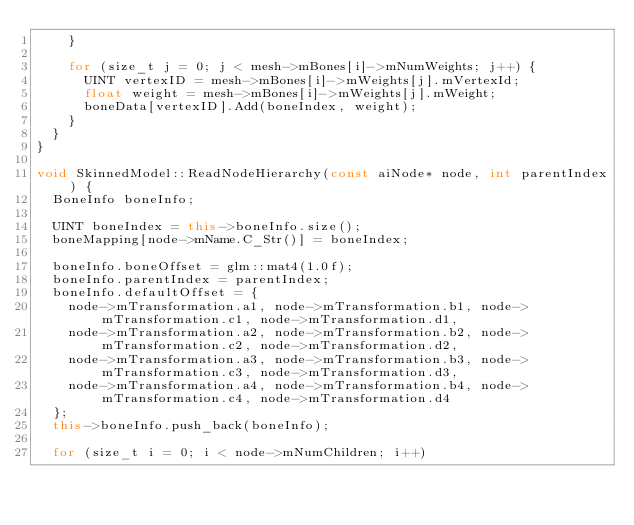<code> <loc_0><loc_0><loc_500><loc_500><_C++_>		}

		for (size_t j = 0; j < mesh->mBones[i]->mNumWeights; j++) {
			UINT vertexID = mesh->mBones[i]->mWeights[j].mVertexId;
			float weight = mesh->mBones[i]->mWeights[j].mWeight;
			boneData[vertexID].Add(boneIndex, weight);
		}
	}
}

void SkinnedModel::ReadNodeHierarchy(const aiNode* node, int parentIndex) {
	BoneInfo boneInfo;

	UINT boneIndex = this->boneInfo.size();
	boneMapping[node->mName.C_Str()] = boneIndex;

	boneInfo.boneOffset = glm::mat4(1.0f);
	boneInfo.parentIndex = parentIndex;
	boneInfo.defaultOffset = {
		node->mTransformation.a1, node->mTransformation.b1, node->mTransformation.c1, node->mTransformation.d1,
		node->mTransformation.a2, node->mTransformation.b2, node->mTransformation.c2, node->mTransformation.d2,
		node->mTransformation.a3, node->mTransformation.b3, node->mTransformation.c3, node->mTransformation.d3,
		node->mTransformation.a4, node->mTransformation.b4, node->mTransformation.c4, node->mTransformation.d4
	};
	this->boneInfo.push_back(boneInfo);

	for (size_t i = 0; i < node->mNumChildren; i++)</code> 